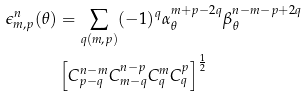<formula> <loc_0><loc_0><loc_500><loc_500>\epsilon _ { m , p } ^ { n } ( \theta ) & = \sum _ { q ( m , p ) } ( - 1 ) ^ { q } \alpha _ { \theta } ^ { m + p - 2 q } \beta _ { \theta } ^ { n - m - p + 2 q } \\ & \left [ C ^ { n - m } _ { p - q } C ^ { n - p } _ { m - q } C ^ { m } _ { q } C ^ { p } _ { q } \right ] ^ { \frac { 1 } { 2 } }</formula> 